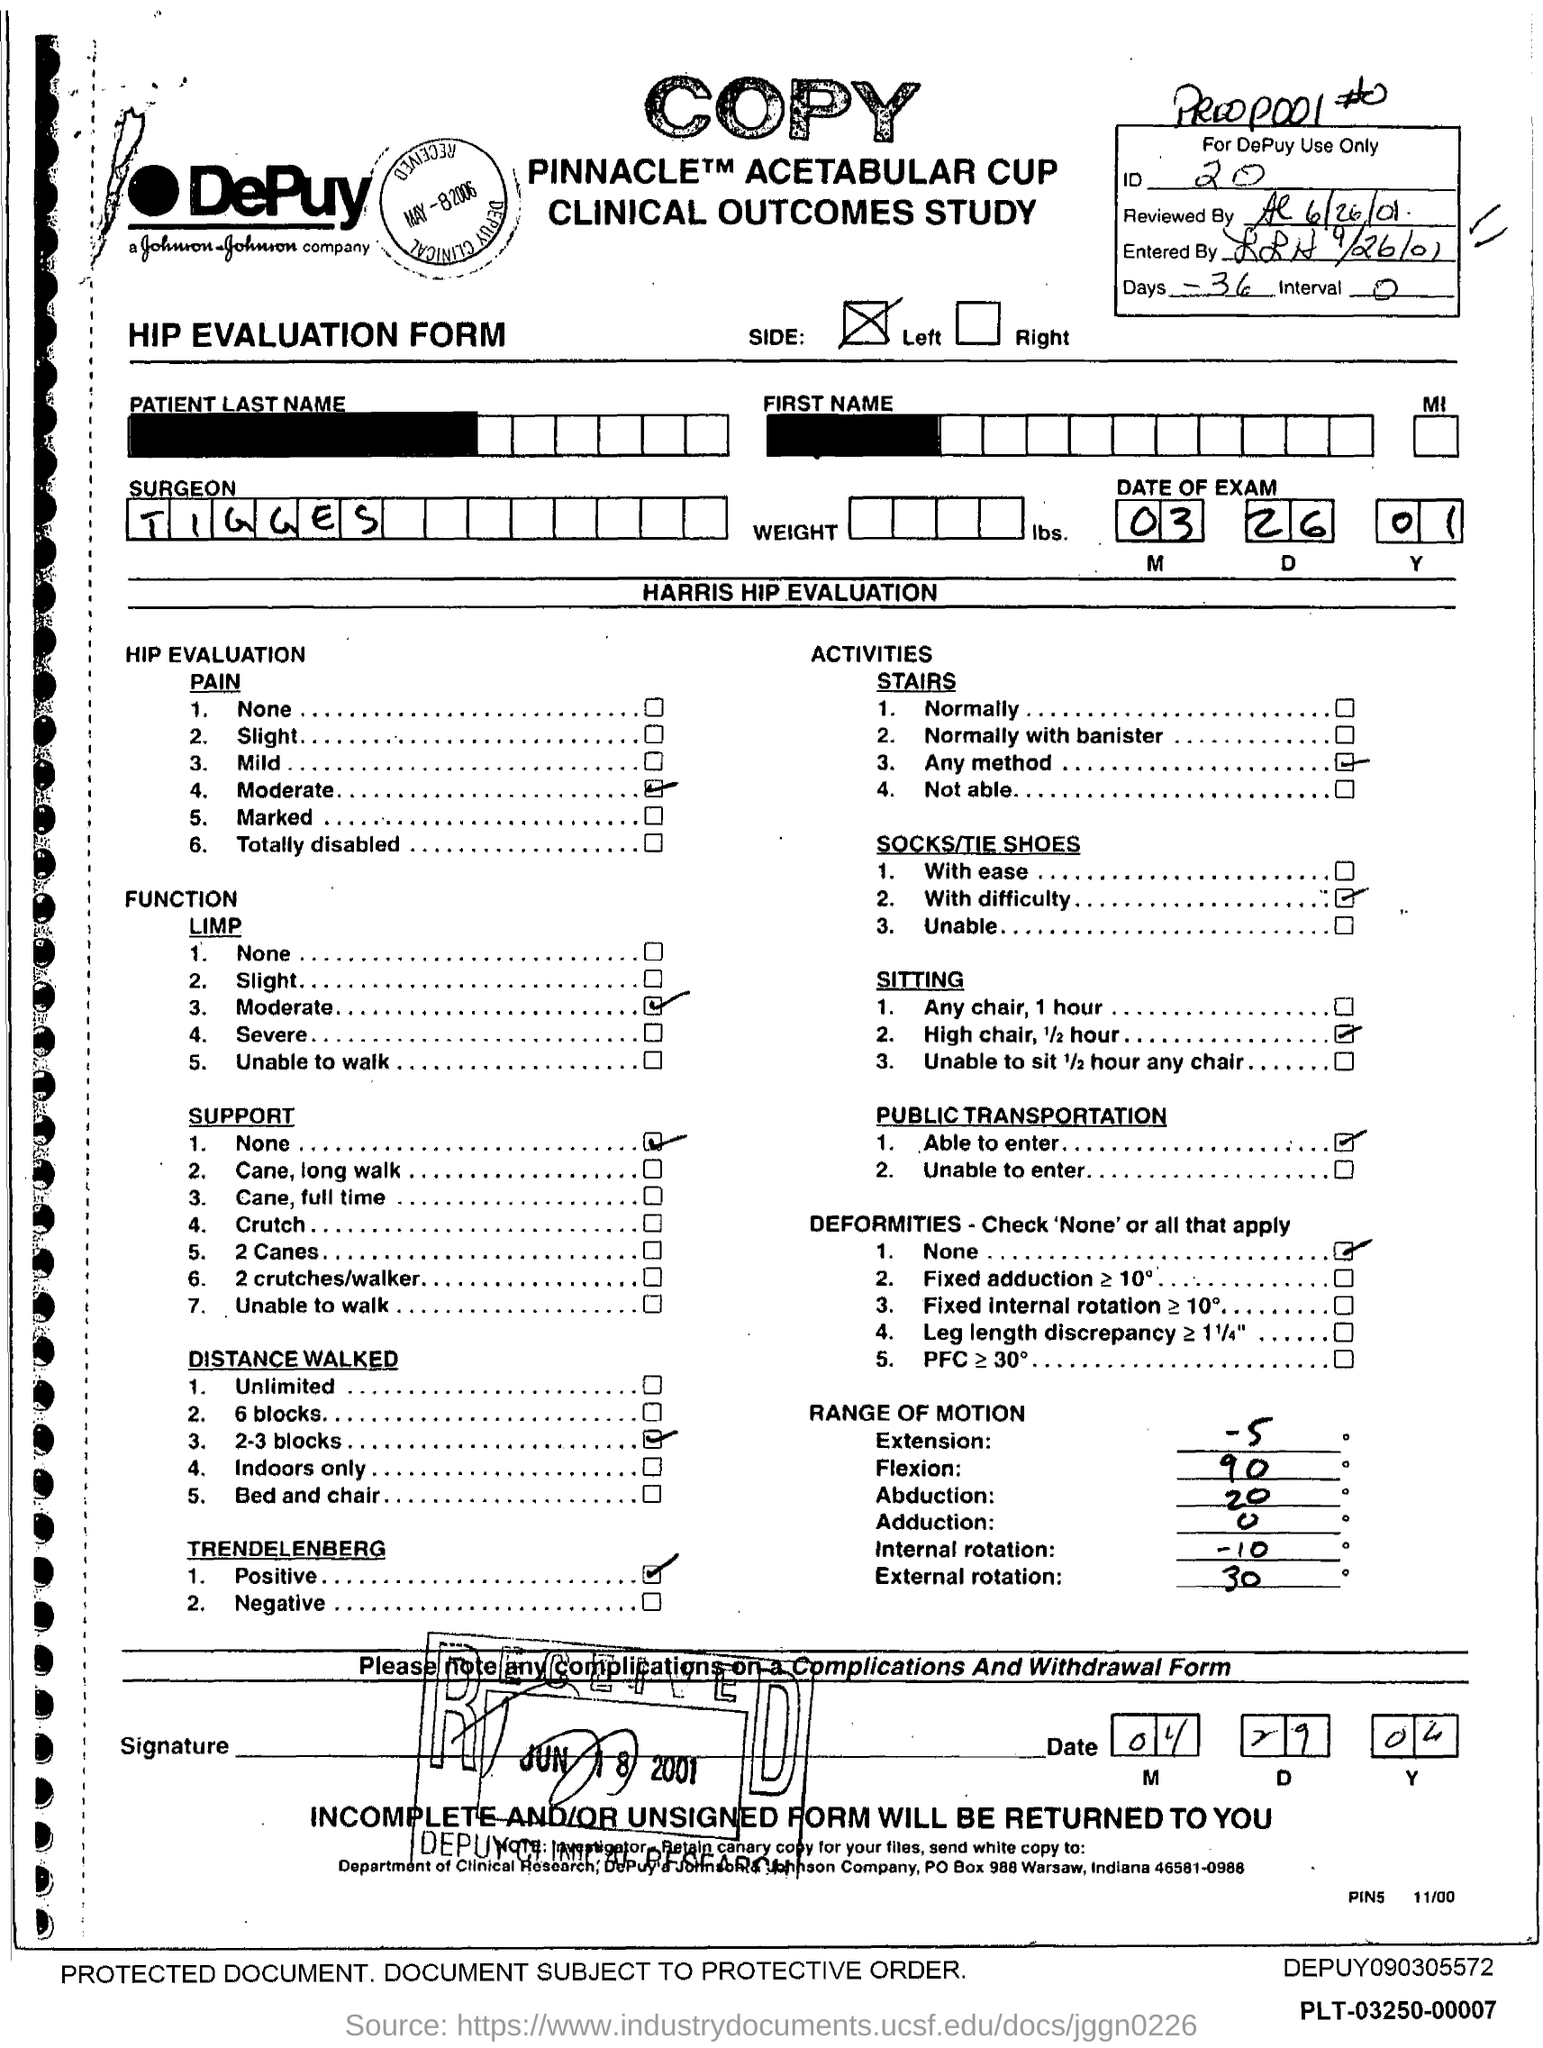What is the id no.?
Offer a terse response. 20. What is the name of the surgeon ?
Offer a terse response. Tigges. What is the po box no. johnson & johnson company ?
Provide a succinct answer. 988. In which state is johnson & johnson company at?
Keep it short and to the point. Indiana. 